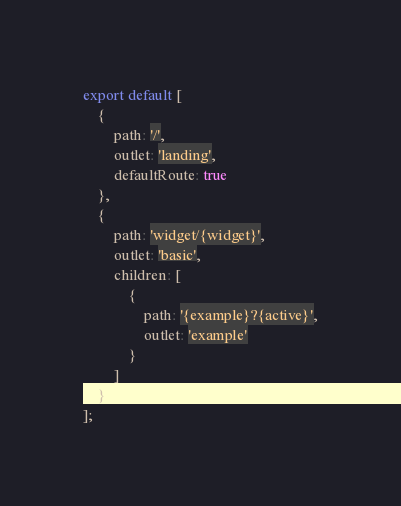<code> <loc_0><loc_0><loc_500><loc_500><_TypeScript_>export default [
	{
		path: '/',
		outlet: 'landing',
		defaultRoute: true
	},
	{
		path: 'widget/{widget}',
		outlet: 'basic',
		children: [
			{
				path: '{example}?{active}',
				outlet: 'example'
			}
		]
	}
];
</code> 